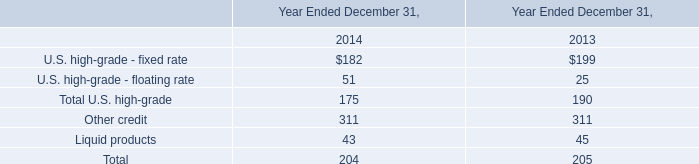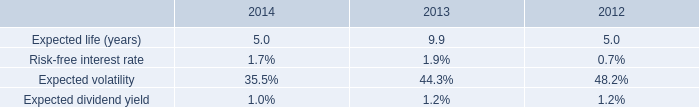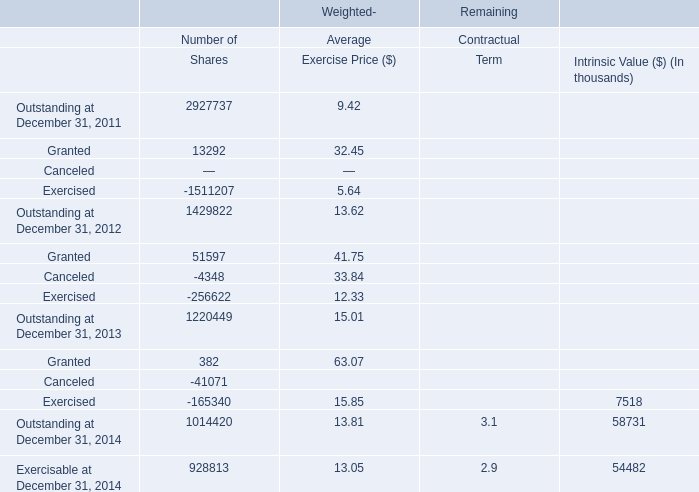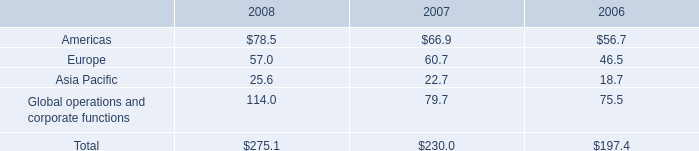what was the percentage change in total rent expense from 2006 to 2007? 
Computations: ((37.1 - 31.1) / 31.1)
Answer: 0.19293. 